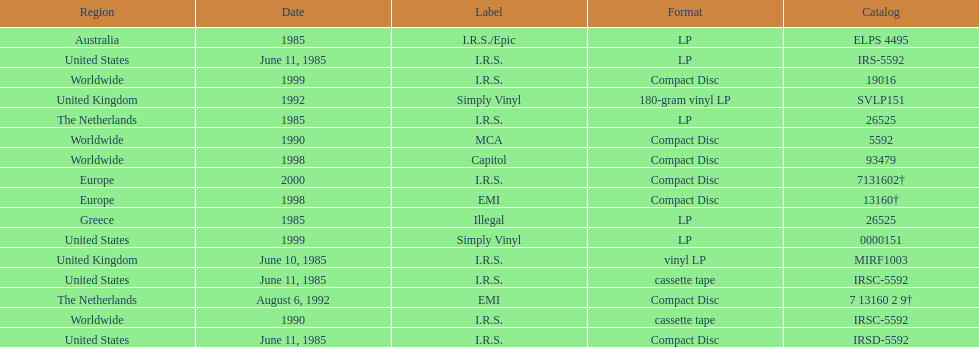What was the date of the first vinyl lp release? June 10, 1985. 